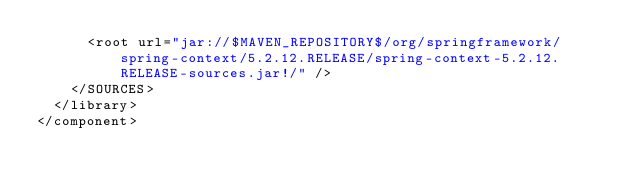<code> <loc_0><loc_0><loc_500><loc_500><_XML_>      <root url="jar://$MAVEN_REPOSITORY$/org/springframework/spring-context/5.2.12.RELEASE/spring-context-5.2.12.RELEASE-sources.jar!/" />
    </SOURCES>
  </library>
</component></code> 